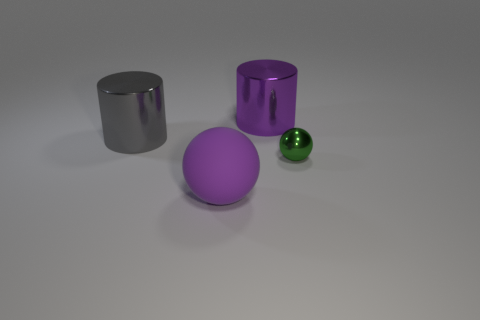What material is the large object that is the same color as the large ball?
Offer a terse response. Metal. There is a large ball; does it have the same color as the cylinder that is right of the matte ball?
Provide a short and direct response. Yes. Is the number of big rubber cylinders greater than the number of purple cylinders?
Give a very brief answer. No. The green object that is the same shape as the large purple matte object is what size?
Your response must be concise. Small. Does the small sphere have the same material as the purple object that is behind the metal ball?
Provide a short and direct response. Yes. How many things are either small metal spheres or tiny cyan rubber spheres?
Give a very brief answer. 1. There is a purple object that is in front of the tiny green metal sphere; is its size the same as the purple thing behind the small green shiny object?
Your answer should be compact. Yes. What number of blocks are either big purple rubber things or green metal things?
Your answer should be compact. 0. Is there a red sphere?
Keep it short and to the point. No. How many objects are large objects on the left side of the big purple metallic cylinder or large gray cylinders?
Keep it short and to the point. 2. 